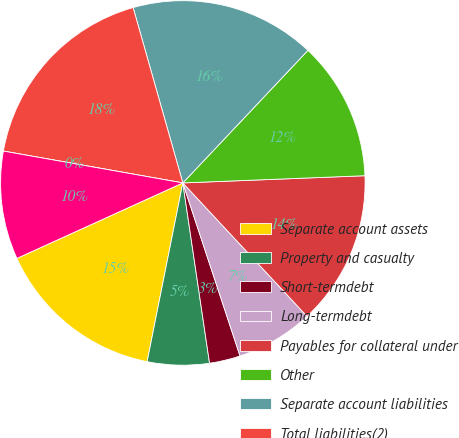Convert chart. <chart><loc_0><loc_0><loc_500><loc_500><pie_chart><fcel>Separate account assets<fcel>Property and casualty<fcel>Short-termdebt<fcel>Long-termdebt<fcel>Payables for collateral under<fcel>Other<fcel>Separate account liabilities<fcel>Total liabilities(2)<fcel>Commonstockatparvalue<fcel>Additional paid-in capital<nl><fcel>15.07%<fcel>5.48%<fcel>2.74%<fcel>6.85%<fcel>13.7%<fcel>12.33%<fcel>16.44%<fcel>17.81%<fcel>0.0%<fcel>9.59%<nl></chart> 